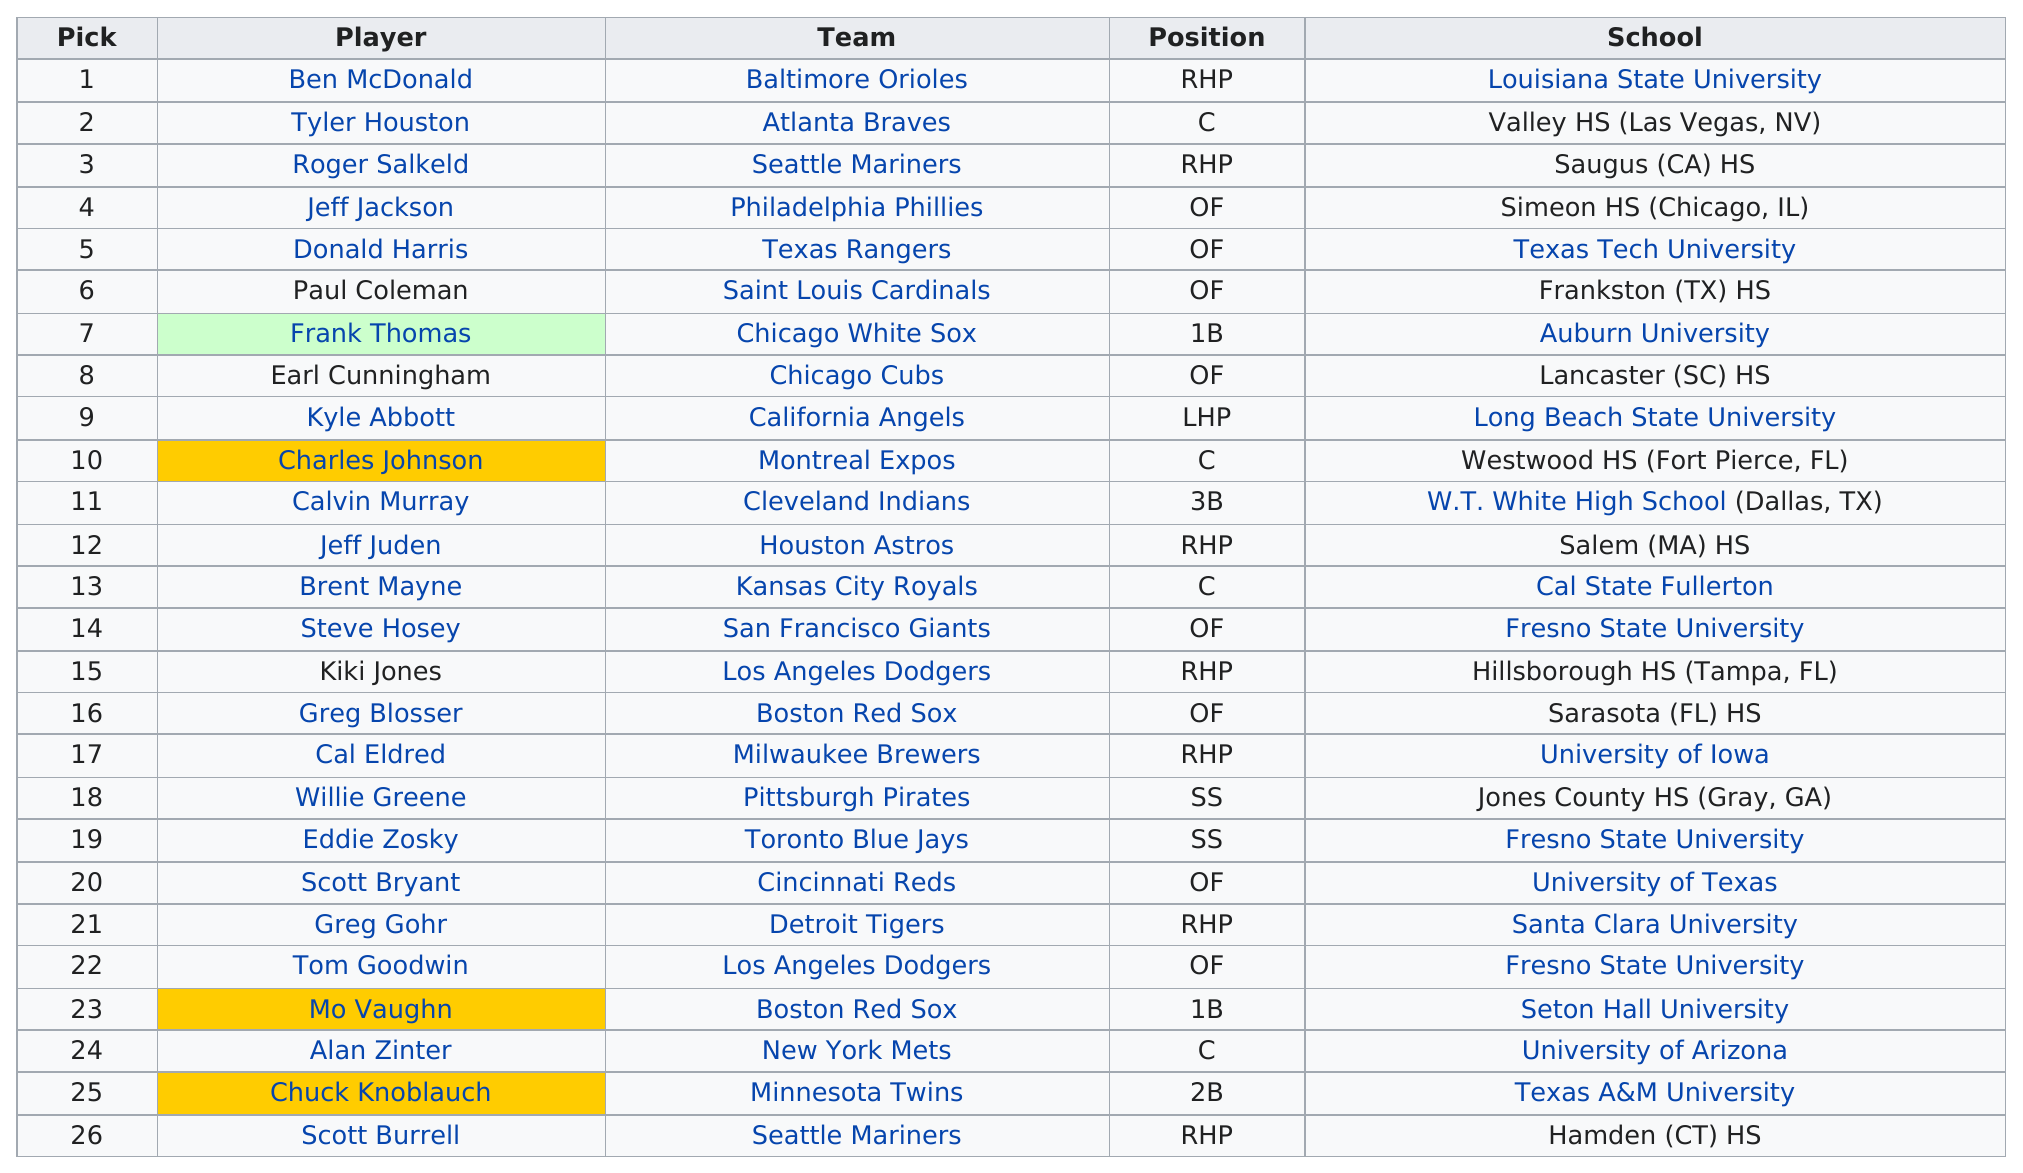List a handful of essential elements in this visual. Ben McDonald is the only player in the top 26 picks who was drafted from Louisiana State University. There are currently three players from Fresno. The higher round pick for the Rhp belonged to the Baltimore Orioles, who received it from the Seattle Mariners, Los Angeles Dodgers, and Houston Astros. A total of two players named Jeff were drafted. The player selected in the first round of the 1989 Major League Baseball Draft, Scott Burrell, was the last player chosen in that round. 